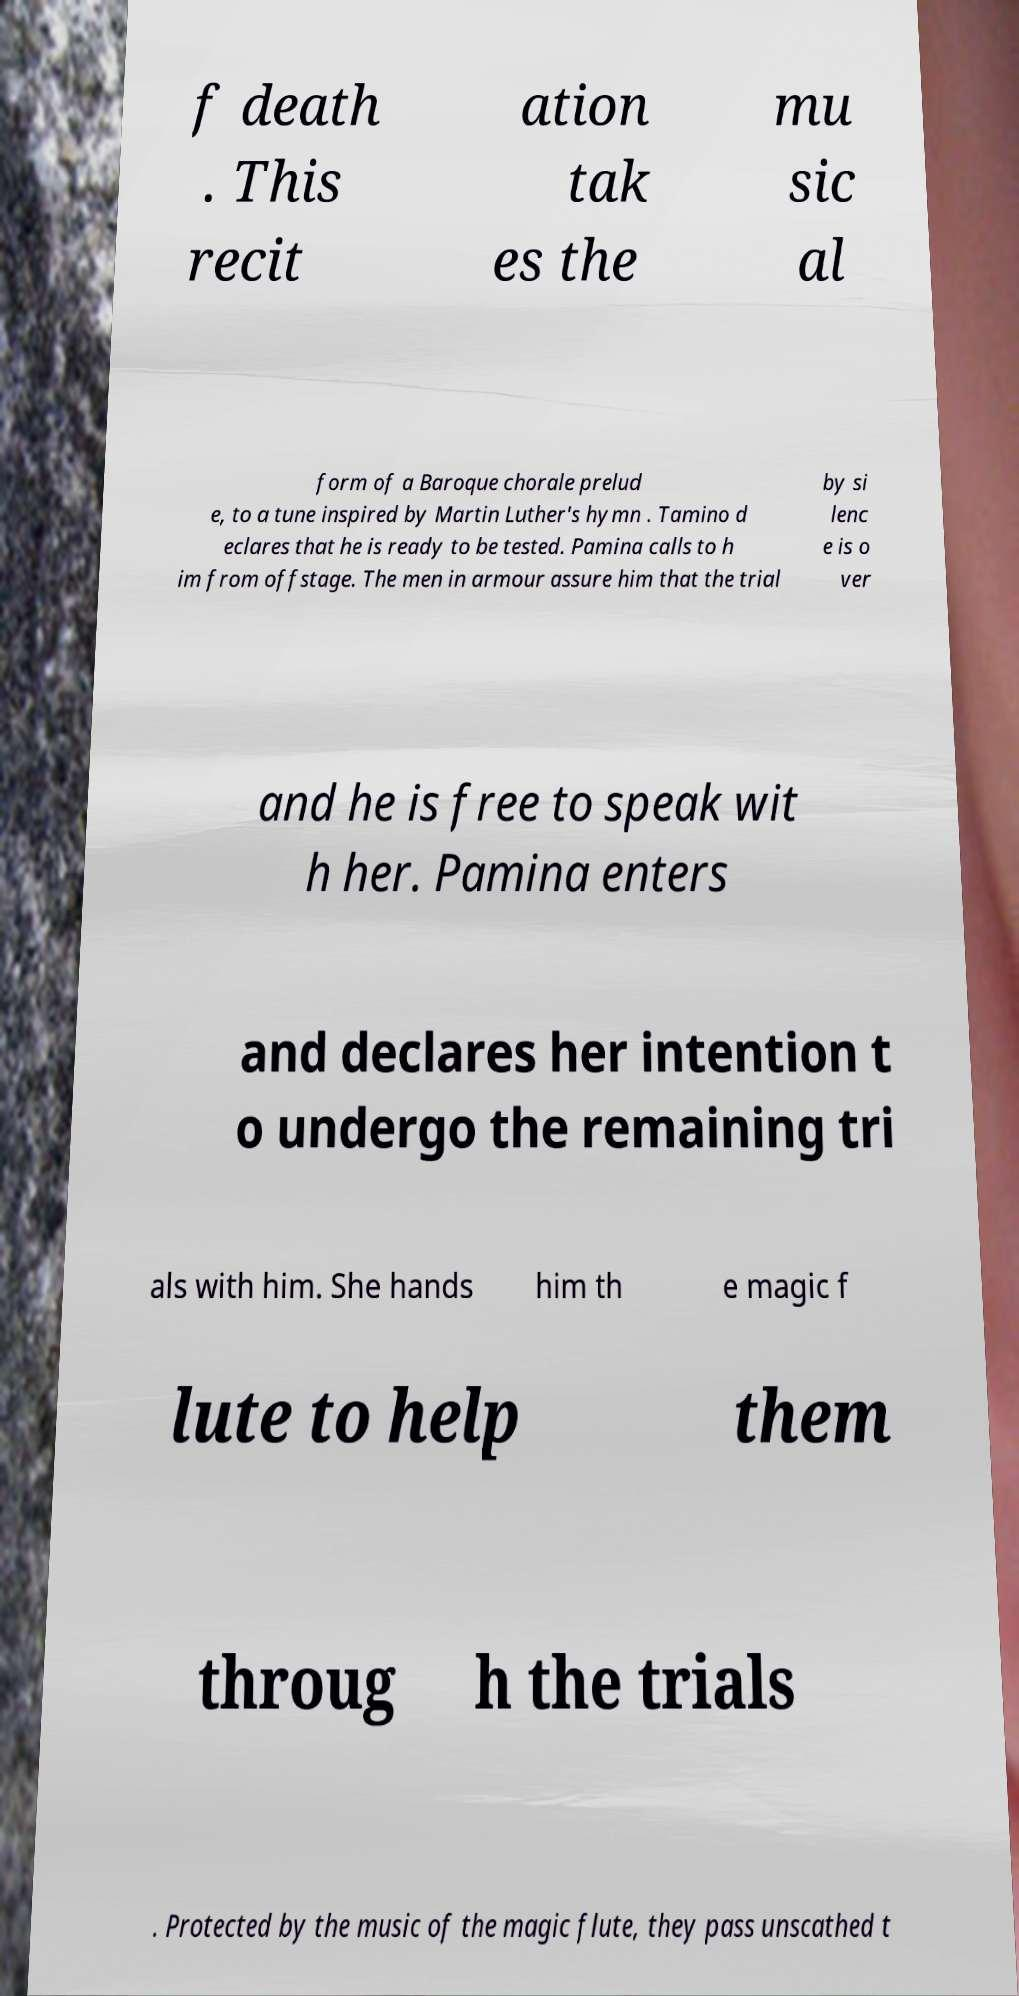I need the written content from this picture converted into text. Can you do that? f death . This recit ation tak es the mu sic al form of a Baroque chorale prelud e, to a tune inspired by Martin Luther's hymn . Tamino d eclares that he is ready to be tested. Pamina calls to h im from offstage. The men in armour assure him that the trial by si lenc e is o ver and he is free to speak wit h her. Pamina enters and declares her intention t o undergo the remaining tri als with him. She hands him th e magic f lute to help them throug h the trials . Protected by the music of the magic flute, they pass unscathed t 